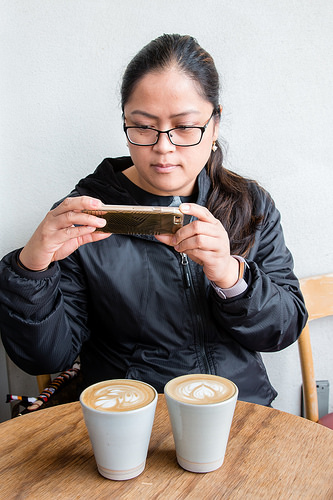<image>
Can you confirm if the coffee is under the phone? Yes. The coffee is positioned underneath the phone, with the phone above it in the vertical space. 